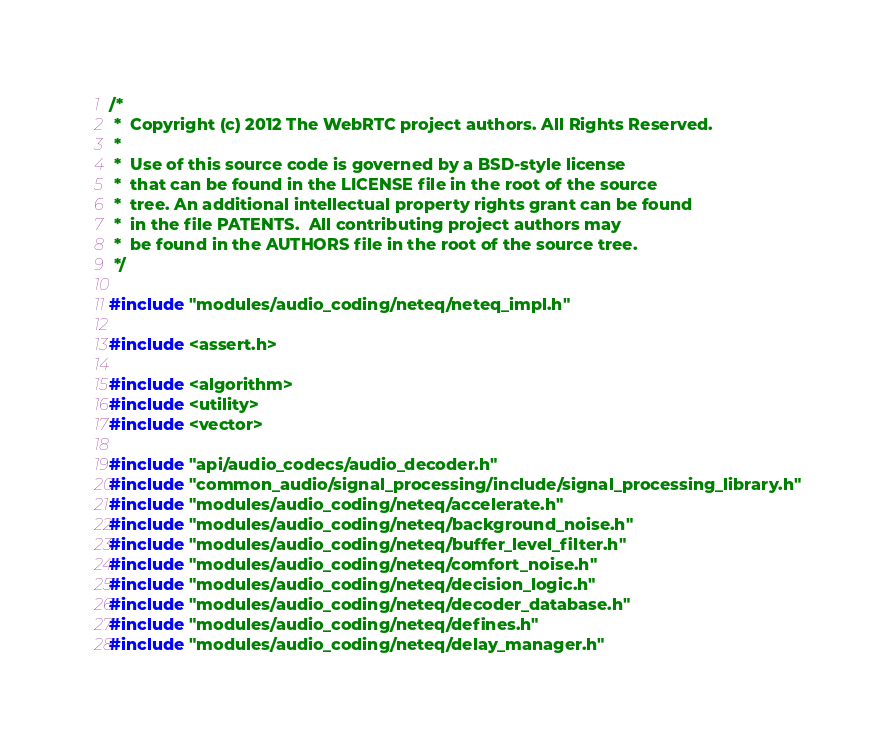<code> <loc_0><loc_0><loc_500><loc_500><_C++_>/*
 *  Copyright (c) 2012 The WebRTC project authors. All Rights Reserved.
 *
 *  Use of this source code is governed by a BSD-style license
 *  that can be found in the LICENSE file in the root of the source
 *  tree. An additional intellectual property rights grant can be found
 *  in the file PATENTS.  All contributing project authors may
 *  be found in the AUTHORS file in the root of the source tree.
 */

#include "modules/audio_coding/neteq/neteq_impl.h"

#include <assert.h>

#include <algorithm>
#include <utility>
#include <vector>

#include "api/audio_codecs/audio_decoder.h"
#include "common_audio/signal_processing/include/signal_processing_library.h"
#include "modules/audio_coding/neteq/accelerate.h"
#include "modules/audio_coding/neteq/background_noise.h"
#include "modules/audio_coding/neteq/buffer_level_filter.h"
#include "modules/audio_coding/neteq/comfort_noise.h"
#include "modules/audio_coding/neteq/decision_logic.h"
#include "modules/audio_coding/neteq/decoder_database.h"
#include "modules/audio_coding/neteq/defines.h"
#include "modules/audio_coding/neteq/delay_manager.h"</code> 